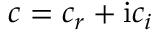<formula> <loc_0><loc_0><loc_500><loc_500>c = c _ { r } + i c _ { i }</formula> 